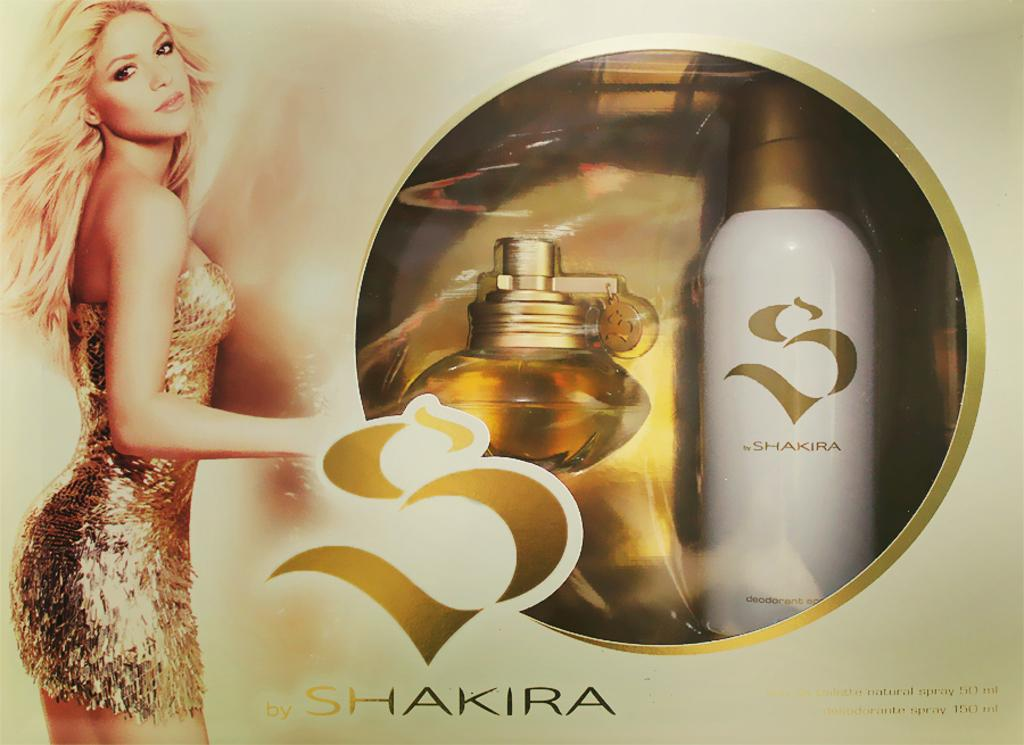<image>
Present a compact description of the photo's key features. Box for a set of perfume that says the word Shakira on the bottom. 